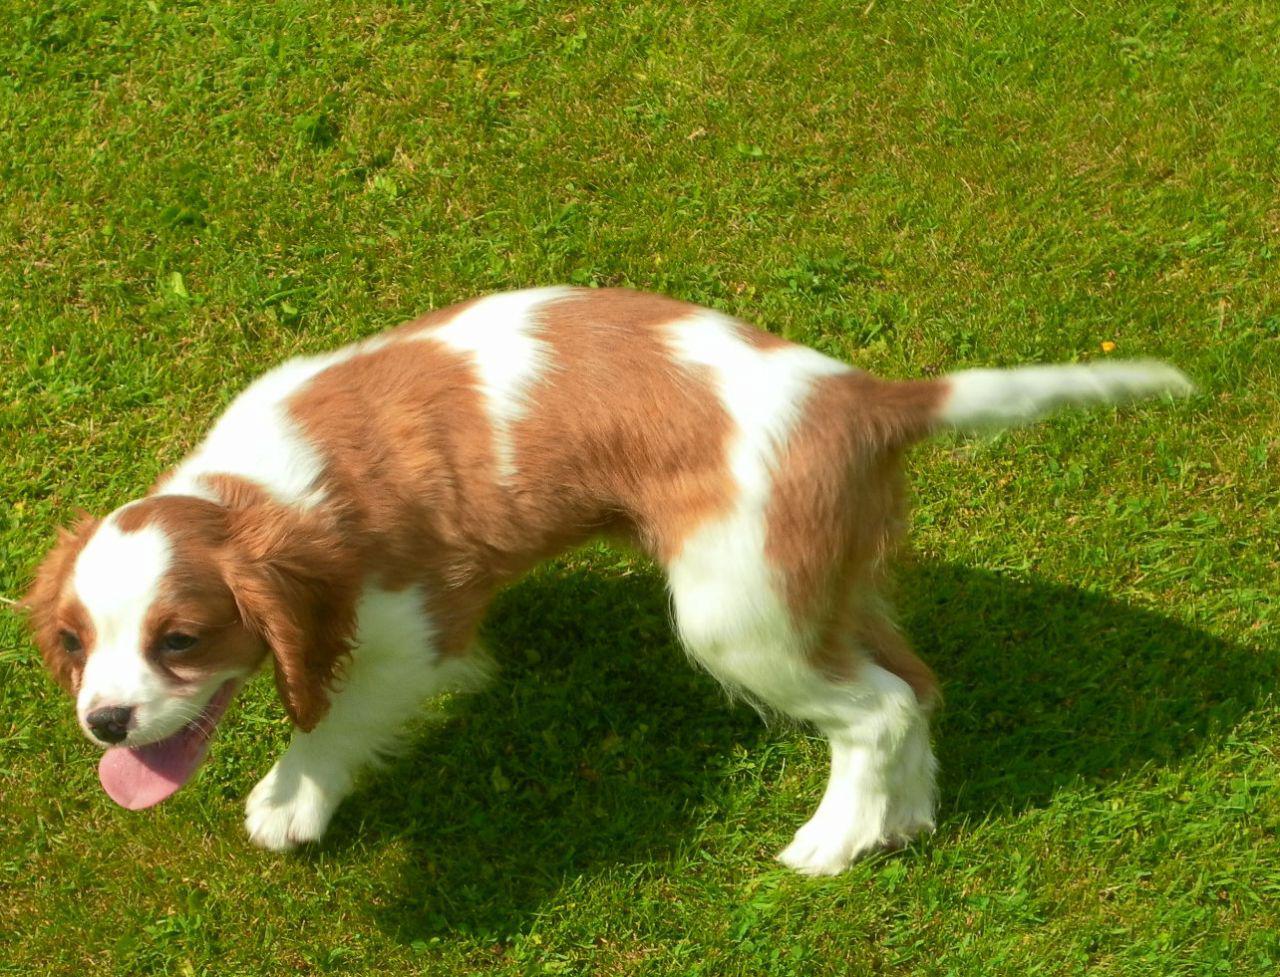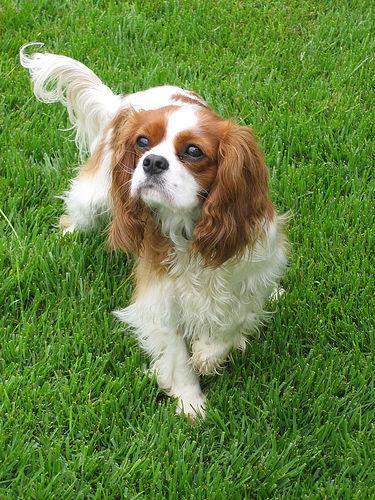The first image is the image on the left, the second image is the image on the right. Considering the images on both sides, is "Left and right images feature one dog on the same type of surface as in the other image." valid? Answer yes or no. Yes. The first image is the image on the left, the second image is the image on the right. Given the left and right images, does the statement "The dog on the right is standing in the green grass outside." hold true? Answer yes or no. Yes. 